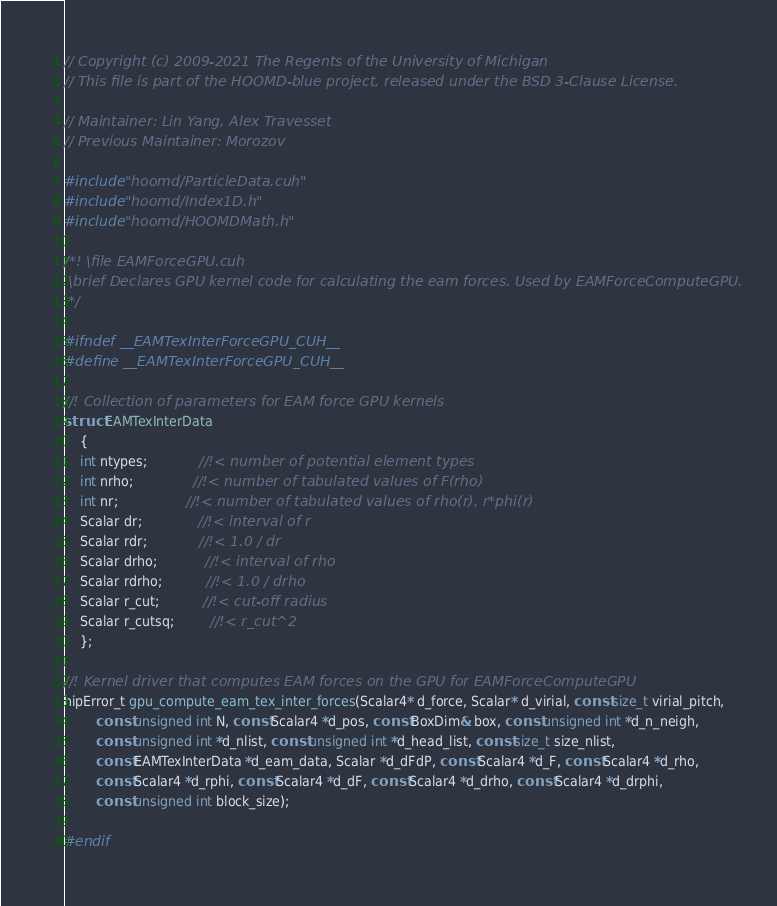Convert code to text. <code><loc_0><loc_0><loc_500><loc_500><_Cuda_>// Copyright (c) 2009-2021 The Regents of the University of Michigan
// This file is part of the HOOMD-blue project, released under the BSD 3-Clause License.

// Maintainer: Lin Yang, Alex Travesset
// Previous Maintainer: Morozov

#include "hoomd/ParticleData.cuh"
#include "hoomd/Index1D.h"
#include "hoomd/HOOMDMath.h"

/*! \file EAMForceGPU.cuh
 \brief Declares GPU kernel code for calculating the eam forces. Used by EAMForceComputeGPU.
 */

#ifndef __EAMTexInterForceGPU_CUH__
#define __EAMTexInterForceGPU_CUH__

//! Collection of parameters for EAM force GPU kernels
struct EAMTexInterData
    {
    int ntypes;             //!< number of potential element types
    int nrho;               //!< number of tabulated values of F(rho)
    int nr;                 //!< number of tabulated values of rho(r), r*phi(r)
    Scalar dr;              //!< interval of r
    Scalar rdr;             //!< 1.0 / dr
    Scalar drho;            //!< interval of rho
    Scalar rdrho;           //!< 1.0 / drho
    Scalar r_cut;           //!< cut-off radius
    Scalar r_cutsq;         //!< r_cut^2
    };

//! Kernel driver that computes EAM forces on the GPU for EAMForceComputeGPU
hipError_t gpu_compute_eam_tex_inter_forces(Scalar4* d_force, Scalar* d_virial, const size_t virial_pitch,
        const unsigned int N, const Scalar4 *d_pos, const BoxDim& box, const unsigned int *d_n_neigh,
        const unsigned int *d_nlist, const unsigned int *d_head_list, const size_t size_nlist,
        const EAMTexInterData *d_eam_data, Scalar *d_dFdP, const Scalar4 *d_F, const Scalar4 *d_rho,
        const Scalar4 *d_rphi, const Scalar4 *d_dF, const Scalar4 *d_drho, const Scalar4 *d_drphi,
        const unsigned int block_size);

#endif
</code> 